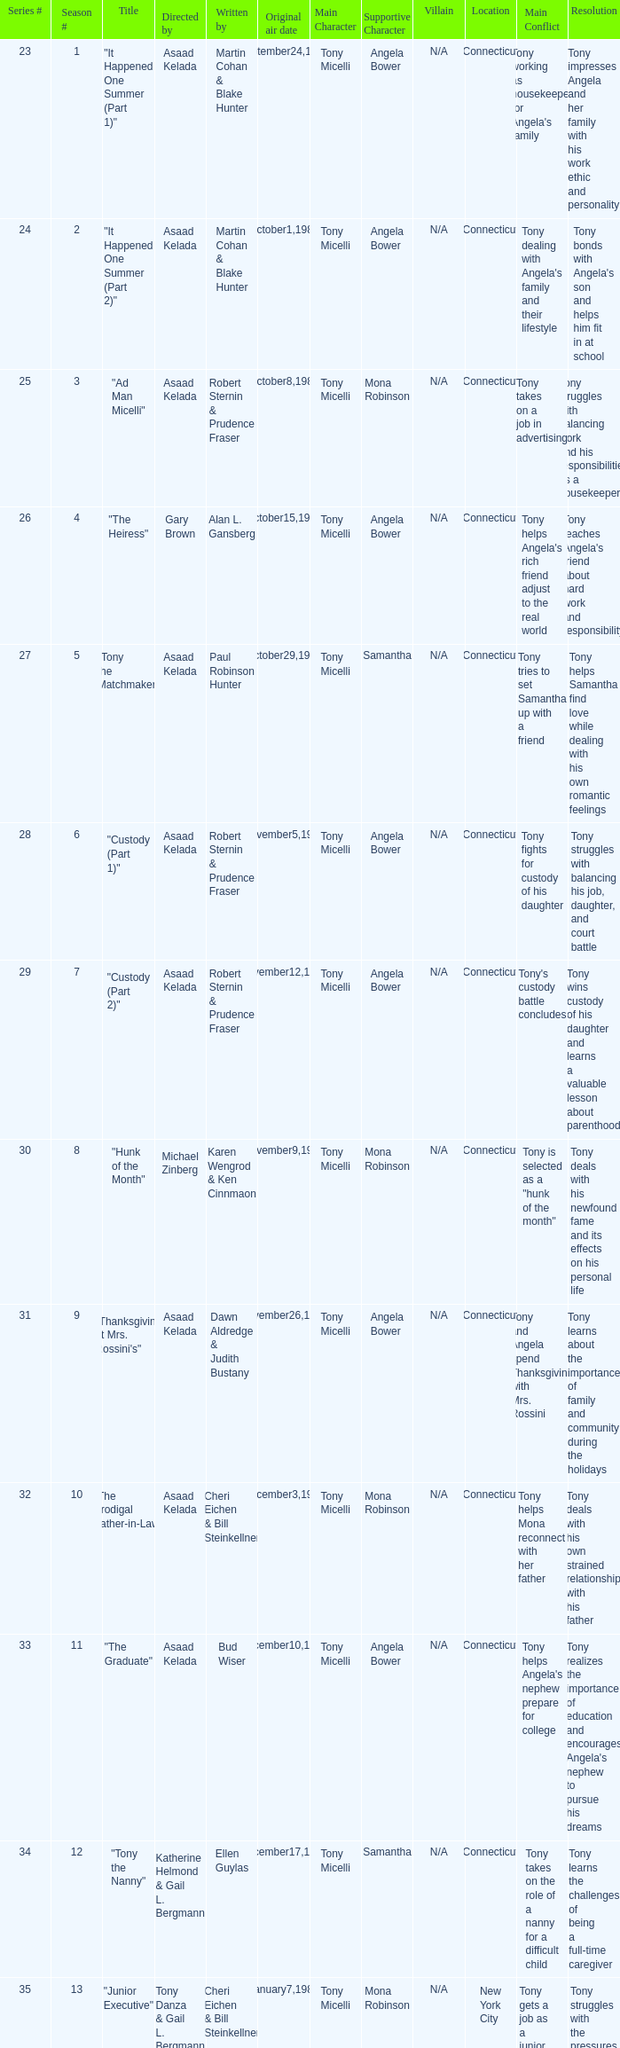What is the date of the episode written by Michael Poryes? January14,1986. Help me parse the entirety of this table. {'header': ['Series #', 'Season #', 'Title', 'Directed by', 'Written by', 'Original air date', 'Main Character', 'Supportive Character', 'Villain', 'Location', 'Main Conflict', 'Resolution'], 'rows': [['23', '1', '"It Happened One Summer (Part 1)"', 'Asaad Kelada', 'Martin Cohan & Blake Hunter', 'September24,1985', 'Tony Micelli', 'Angela Bower', 'N/A', 'Connecticut', "Tony working as housekeeper for Angela's family", 'Tony impresses Angela and her family with his work ethic and personality'], ['24', '2', '"It Happened One Summer (Part 2)"', 'Asaad Kelada', 'Martin Cohan & Blake Hunter', 'October1,1985', 'Tony Micelli', 'Angela Bower', 'N/A', 'Connecticut', "Tony dealing with Angela's family and their lifestyle", "Tony bonds with Angela's son and helps him fit in at school"], ['25', '3', '"Ad Man Micelli"', 'Asaad Kelada', 'Robert Sternin & Prudence Fraser', 'October8,1985', 'Tony Micelli', 'Mona Robinson', 'N/A', 'Connecticut', 'Tony takes on a job in advertising', 'Tony struggles with balancing work and his responsibilities as a housekeeper'], ['26', '4', '"The Heiress"', 'Gary Brown', 'Alan L. Gansberg', 'October15,1985', 'Tony Micelli', 'Angela Bower', 'N/A', 'Connecticut', "Tony helps Angela's rich friend adjust to the real world", "Tony teaches Angela's friend about hard work and responsibility"], ['27', '5', '"Tony the Matchmaker"', 'Asaad Kelada', 'Paul Robinson Hunter', 'October29,1985', 'Tony Micelli', 'Samantha', 'N/A', 'Connecticut', 'Tony tries to set Samantha up with a friend', 'Tony helps Samantha find love while dealing with his own romantic feelings'], ['28', '6', '"Custody (Part 1)"', 'Asaad Kelada', 'Robert Sternin & Prudence Fraser', 'November5,1985', 'Tony Micelli', 'Angela Bower', 'N/A', 'Connecticut', 'Tony fights for custody of his daughter', 'Tony struggles with balancing his job, daughter, and court battle'], ['29', '7', '"Custody (Part 2)"', 'Asaad Kelada', 'Robert Sternin & Prudence Fraser', 'November12,1985', 'Tony Micelli', 'Angela Bower', 'N/A', 'Connecticut', "Tony's custody battle concludes", 'Tony wins custody of his daughter and learns a valuable lesson about parenthood'], ['30', '8', '"Hunk of the Month"', 'Michael Zinberg', 'Karen Wengrod & Ken Cinnmaon', 'November9,1985', 'Tony Micelli', 'Mona Robinson', 'N/A', 'Connecticut', 'Tony is selected as a "hunk of the month"', 'Tony deals with his newfound fame and its effects on his personal life'], ['31', '9', '"Thanksgiving at Mrs. Rossini\'s"', 'Asaad Kelada', 'Dawn Aldredge & Judith Bustany', 'November26,1985', 'Tony Micelli', 'Angela Bower', 'N/A', 'Connecticut', 'Tony and Angela spend Thanksgiving with Mrs. Rossini', 'Tony learns about the importance of family and community during the holidays'], ['32', '10', '"The Prodigal Father-in-Law"', 'Asaad Kelada', 'Cheri Eichen & Bill Steinkellner', 'December3,1985', 'Tony Micelli', 'Mona Robinson', 'N/A', 'Connecticut', 'Tony helps Mona reconnect with her father', 'Tony deals with his own strained relationship with his father'], ['33', '11', '"The Graduate"', 'Asaad Kelada', 'Bud Wiser', 'December10,1985', 'Tony Micelli', 'Angela Bower', 'N/A', 'Connecticut', "Tony helps Angela's nephew prepare for college", "Tony realizes the importance of education and encourages Angela's nephew to pursue his dreams"], ['34', '12', '"Tony the Nanny"', 'Katherine Helmond & Gail L. Bergmann', 'Ellen Guylas', 'December17,1985', 'Tony Micelli', 'Samantha', 'N/A', 'Connecticut', 'Tony takes on the role of a nanny for a difficult child', 'Tony learns the challenges of being a full-time caregiver'], ['35', '13', '"Junior Executive"', 'Tony Danza & Gail L. Bergmann', 'Cheri Eichen & Bill Steinkellner', 'January7,1986', 'Tony Micelli', 'Mona Robinson', 'N/A', 'New York City', 'Tony gets a job as a junior executive', 'Tony struggles with the pressures of corporate life and the toll it takes on his family'], ['36', '14', '"Educating Tony"', 'Asaad Kelada', 'Michael Poryes', 'January14,1986', 'Tony Micelli', 'Angela Bower', 'N/A', 'Connecticut', 'Tony goes back to school', 'Tony learns about the importance of education and how it can improve his career prospects'], ['37', '15', '"Gotta Dance"', 'Asaad Kelada', 'Howard Meyers', 'January21,1986', 'Tony Micelli', 'Mona Robinson', 'N/A', 'Connecticut', 'Tony teaches a dance class', 'Tony learns about the importance of self-expression and following your passions'], ['38', '16', '"The Babysitter"', 'Asaad Kelada', 'Bud Wiser', 'January28,1986', 'Tony Micelli', 'Angela Bower', 'N/A', 'Connecticut', "Tony takes care of Angela's son while she's away", 'Tony learns the challenges of being a single parent'], ['39', '17', '"Jonathan Plays Cupid "', 'Asaad Kelada', 'Paul Robinson Hunter', 'February11,1986', 'Tony Micelli', 'Angela Bower', 'N/A', 'Connecticut', 'Tony helps Jonathan set up a romantic evening', 'Tony reflects on his own romantic life and learns about the importance of love and connection'], ['40', '18', '"When Worlds Collide"', 'Asaad Kelada', 'Karen Wengrod & Ken Cinnamon', 'February18,1986', 'Tony Micelli', 'Mona Robinson', 'N/A', 'Connecticut', "Tony's ex-wife comes to town", 'Tony learns to navigate his complicated relationships and focus on his priorities'], ['41', '19', '"Losers and Other Strangers"', 'Asaad Kelada', 'Seth Weisbord', 'February25,1986', 'Tony Micelli', 'Angela Bower', 'N/A', 'Connecticut', 'Tony throws a party for his disabled friend', 'Tony learns about empathy and the challenges faced by those with disabilities'], ['42', '20', '"Tony for President"', 'Asaad Kelada', 'Howard Meyers', 'March4,1986', 'Tony Micelli', 'Mona Robinson', 'N/A', 'Connecticut', 'Tony runs for local office', 'Tony learns about the challenges of politics and the importance of civic duty'], ['43', '21', '"Not With My Client, You Don\'t"', 'Asaad Kelada', 'Dawn Aldredge & Judith Bustany', 'March18,1986', 'Tony Micelli', 'Angela Bower', 'N/A', 'Connecticut', 'Tony helps Angela with a difficult client', 'Tony learns about the importance of loyalty and trust in business relationships'], ['45', '23', '"There\'s No Business Like Shoe Business"', 'Asaad Kelada', 'Karen Wengrod & Ken Cinnamon', 'April1,1986', 'Tony Micelli', 'Mona Robinson', 'N/A', 'New York City', 'Tony attends a shoe conference', 'Tony learns about the importance of networking and marketing in business'], ['46', '24', '"The Unnatural"', 'Jim Drake', 'Ellen Guylas', 'April8,1986', 'Tony Micelli', 'Angela Bower', 'N/A', 'Connecticut', "Tony coaches Angela's son's baseball team", 'Tony learns about sportsmanship and the importance of having fun while playing sports.']]} 